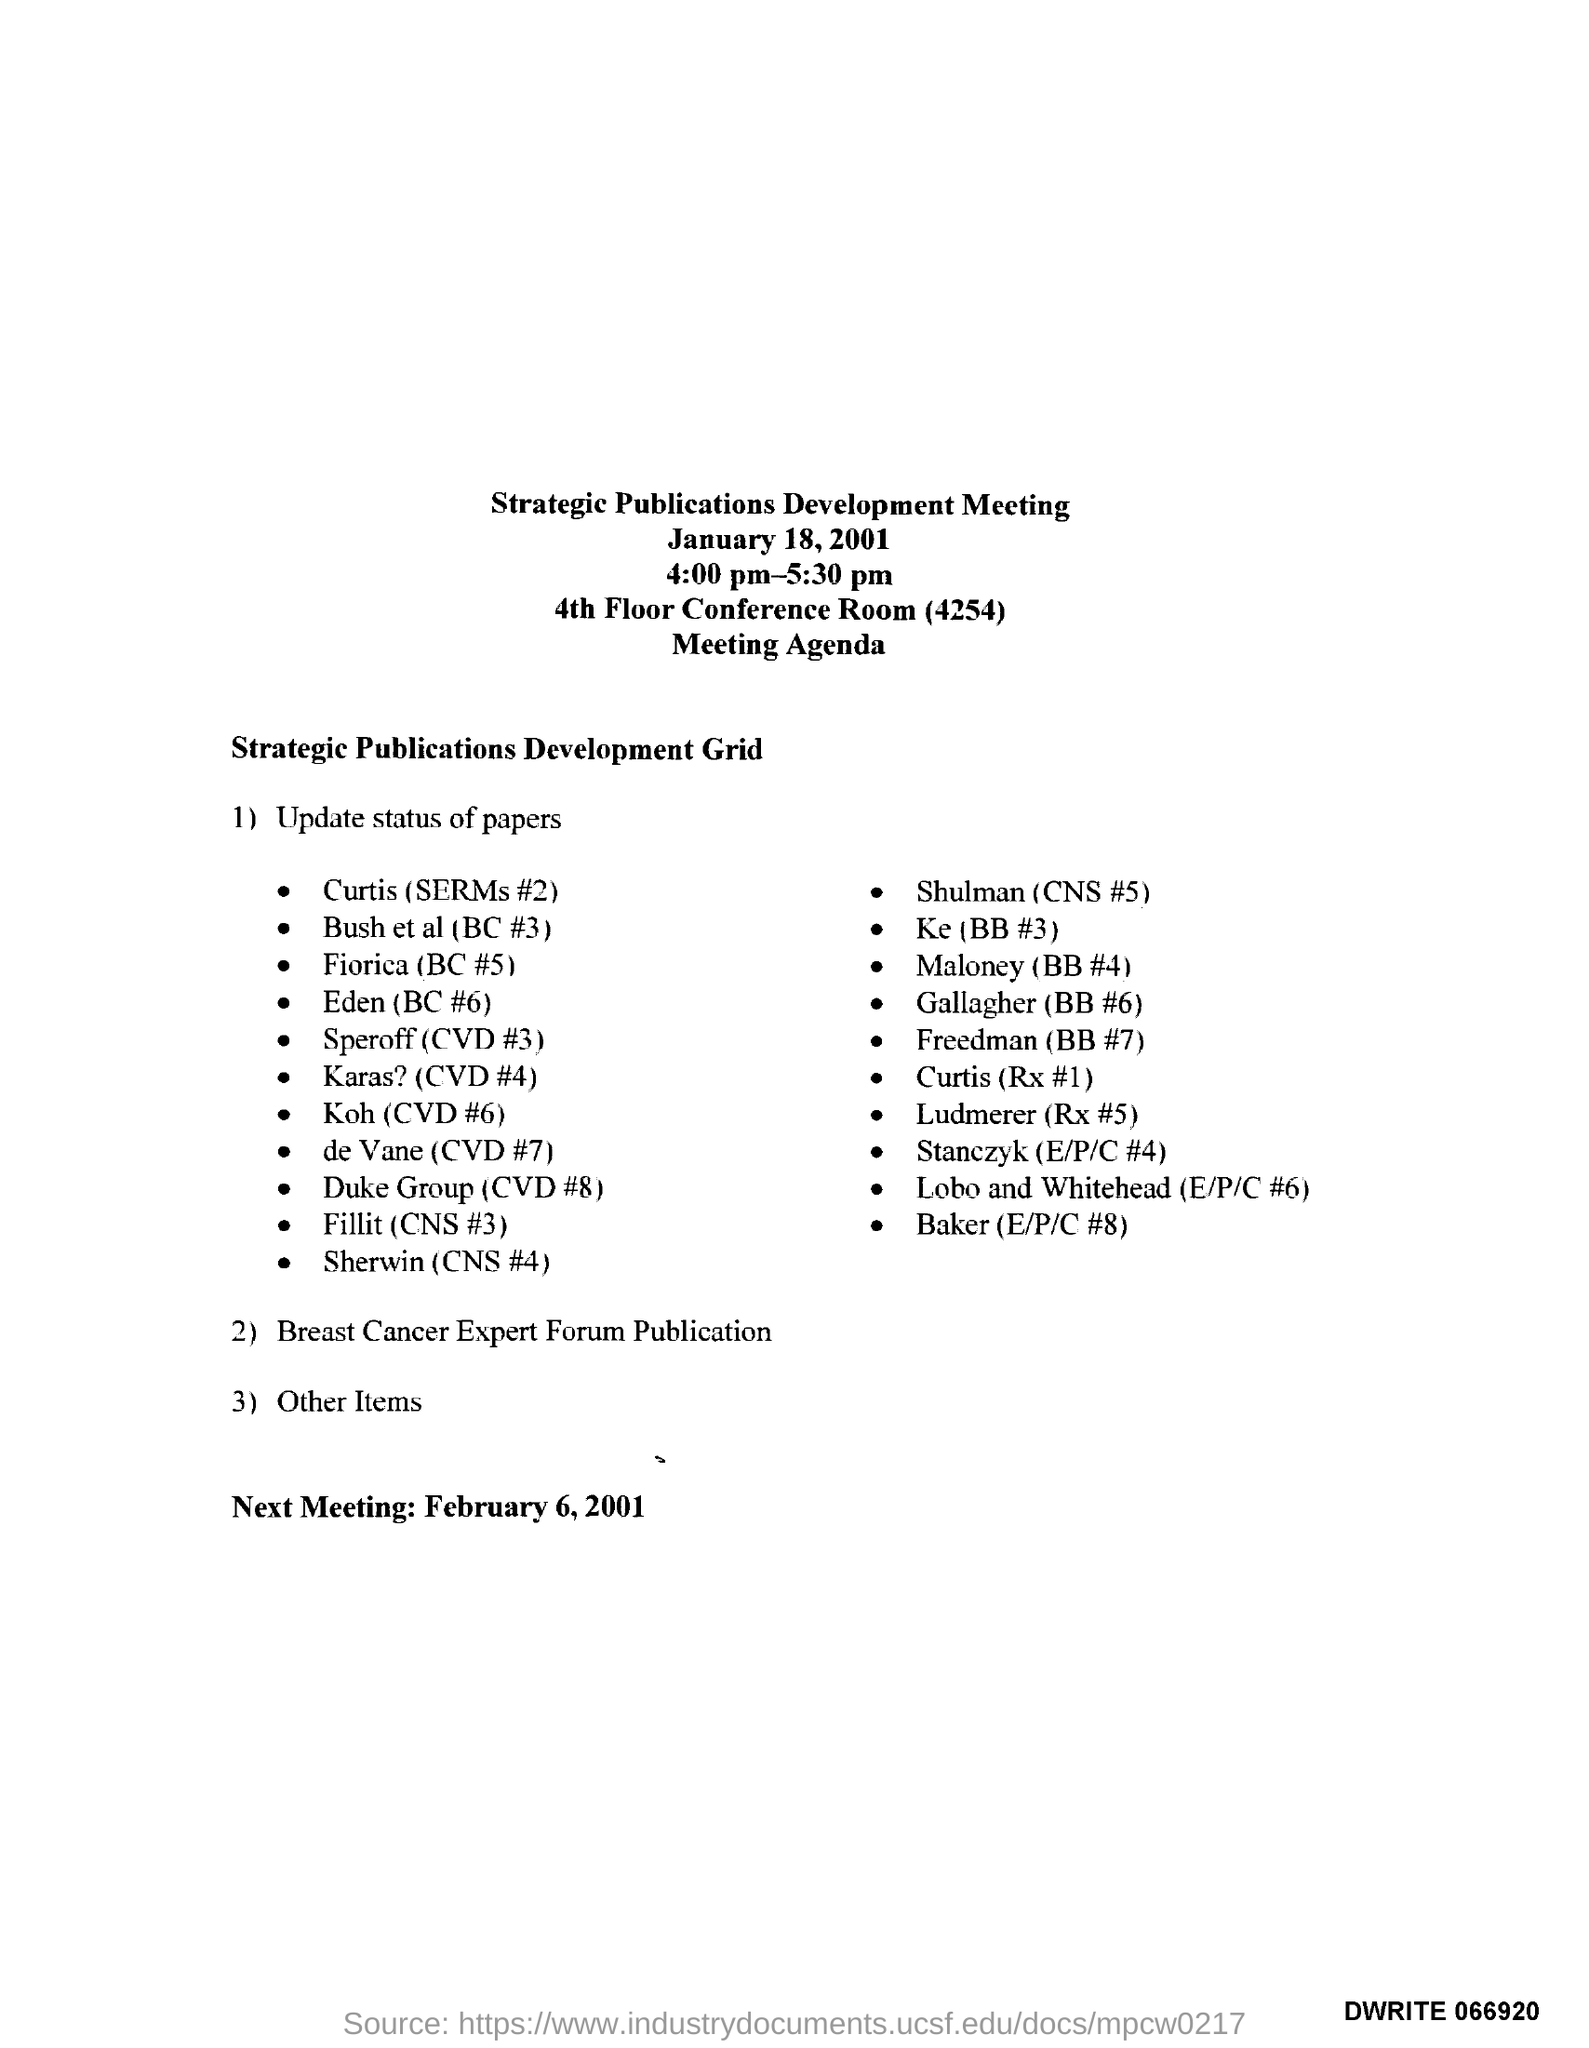List a handful of essential elements in this visual. The next meeting is scheduled to take place on February 6, 2001, according to the agenda. The Strategic Publications Development Meeting will be held in the 4th floor conference room. The Strategic Publications Development Meeting was held on January 18, 2001. The Strategic Publications Development Meeting is scheduled to take place from 4:00 pm to 5:30 pm. 